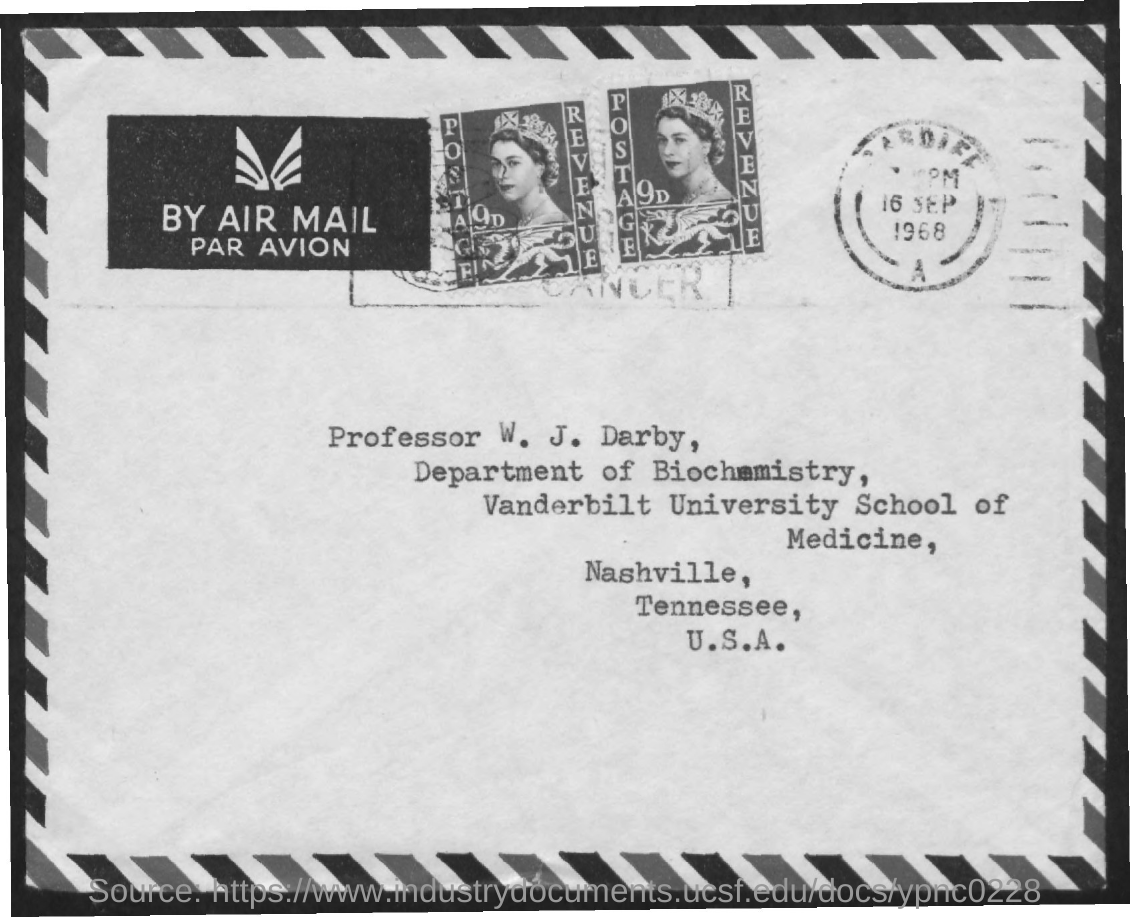To Whom is this letter addressed to?
Ensure brevity in your answer.  PROFESSOR W. J. DARBY. 